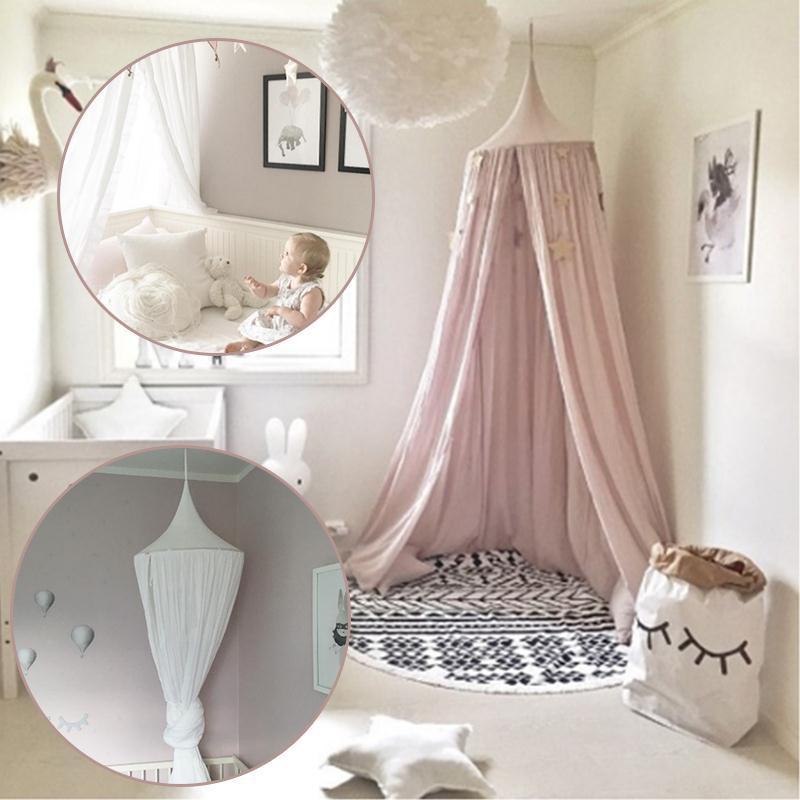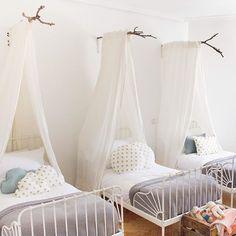The first image is the image on the left, the second image is the image on the right. Considering the images on both sides, is "There is a baby visible in one image." valid? Answer yes or no. Yes. The first image is the image on the left, the second image is the image on the right. Given the left and right images, does the statement "The left and right image contains a total of two open canopies." hold true? Answer yes or no. No. 